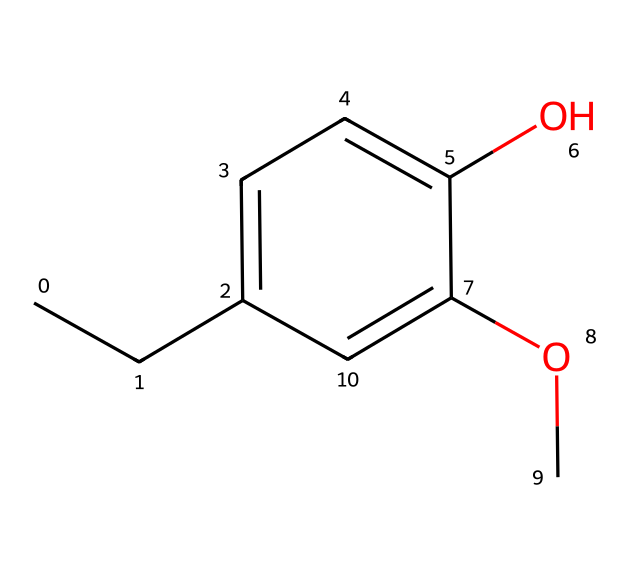What is the chemical name of this compound? The provided SMILES notation corresponds to a structure featuring a methoxy group and a hydroxyl group attached to a substituted aromatic ring, which is characteristic of eugenol.
Answer: eugenol How many carbon atoms are present in the structure? By analyzing the SMILES notation, we can count the carbon atoms represented. Each "C" corresponds to a carbon atom, totaling to 10 in this case.
Answer: 10 How many hydroxyl groups are present? The presence of an "O" directly bonded to a carbon in the aromatic ring signifies the presence of a hydroxyl (-OH) group, and in this structure, there is only one such group.
Answer: 1 What type of chemical functional group is indicated by this structure? The structure contains both a hydroxyl group (-OH) and an ether group (-O-), which are typical of phenolic compounds. This indicates the presence of phenolic hydroxyl functional groups.
Answer: phenolic Does this compound contain any double bonds? The structure reveals aromaticity in the benzene ring and the presence of a methoxy group suggests there are indeed double bonds within the aromatic system as part of the conjugated system of the ring.
Answer: yes Can this compound be classified as an antioxidant? Eugenol, as a phenolic compound, has been recognized for its antioxidant properties due to the hydroxyl groups that can donate protons, stabilizing free radicals.
Answer: yes 